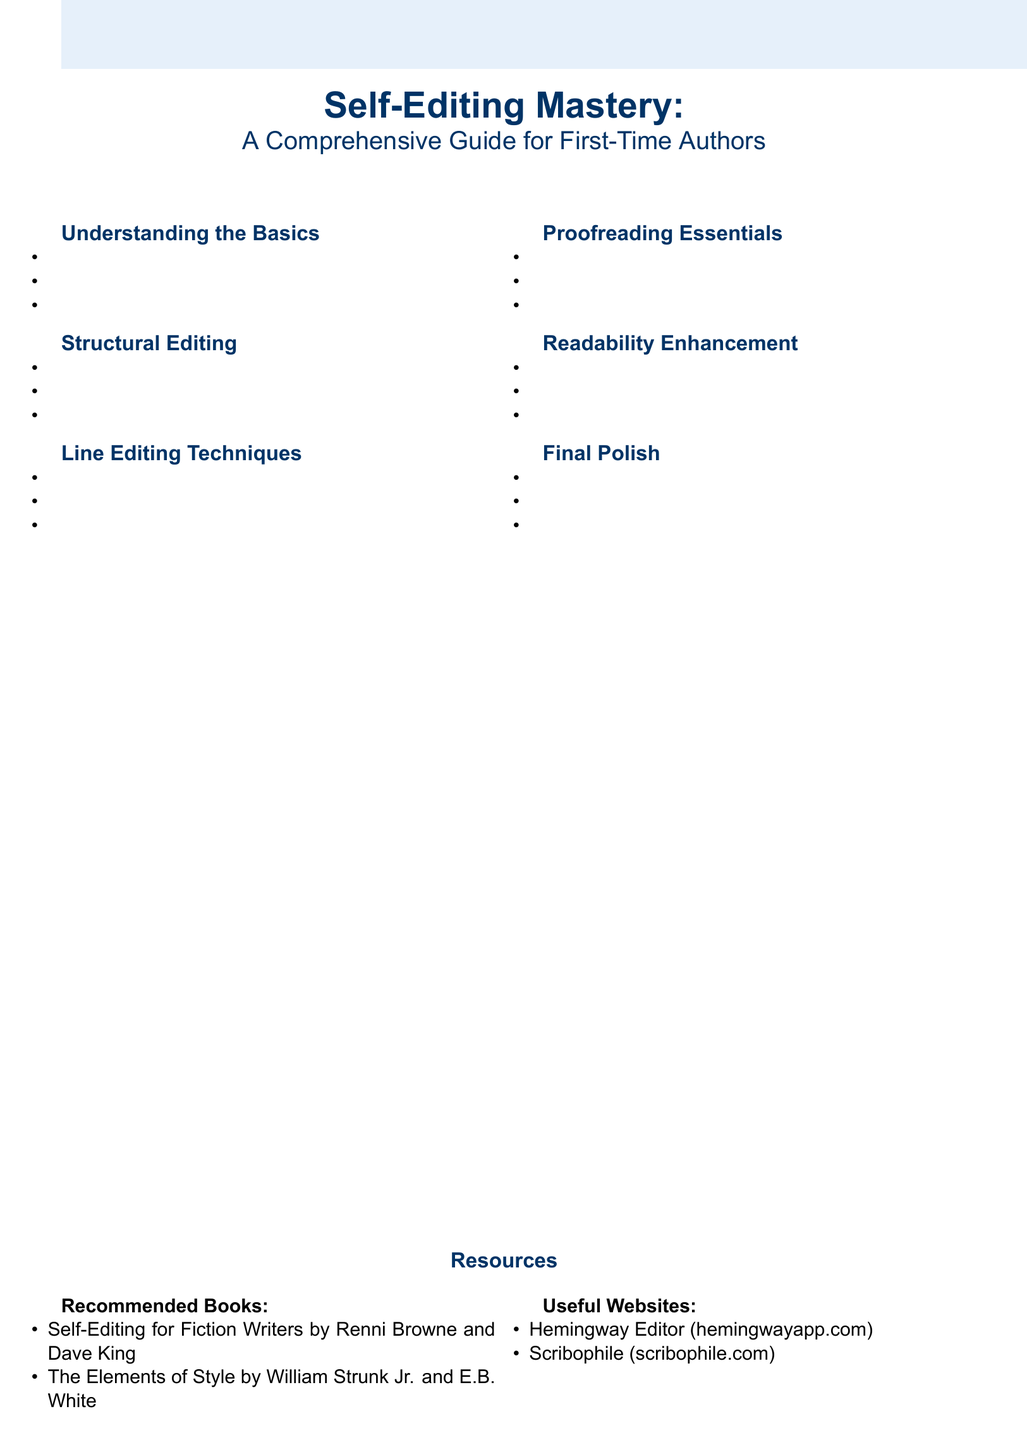What is the title of the guide? The title is prominently displayed at the top of the document, reflecting its purpose for authors.
Answer: Self-Editing Mastery How many sections are listed in the guide? The document provides a list of sections, making it easy to count them.
Answer: 6 What is one technique suggested for enhancing readability? One of the techniques mentioned focuses on improving the flow and rhythm of writing.
Answer: Reading aloud for rhythm and flow Name one recommended book on self-editing. The document lists specific books that authors can refer to for guidance.
Answer: Self-Editing for Fiction Writers What type of editing focuses on character development? The guide outlines various editing techniques and identifies one that pertains to characters.
Answer: Structural Editing What is a common mistake new authors make? The document highlights specific pitfalls that authors often encounter during writing.
Answer: Common mistakes new authors make Which website is mentioned that helps with editing? The resources section includes useful websites that assist authors in the editing process.
Answer: Hemingway Editor What is the color scheme used in the document? The document utilizes specific colors consistently throughout its design for visual appeal.
Answer: Light blue and dark blue 